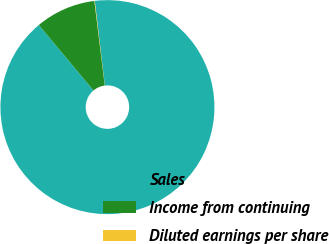<chart> <loc_0><loc_0><loc_500><loc_500><pie_chart><fcel>Sales<fcel>Income from continuing<fcel>Diluted earnings per share<nl><fcel>90.81%<fcel>9.13%<fcel>0.06%<nl></chart> 